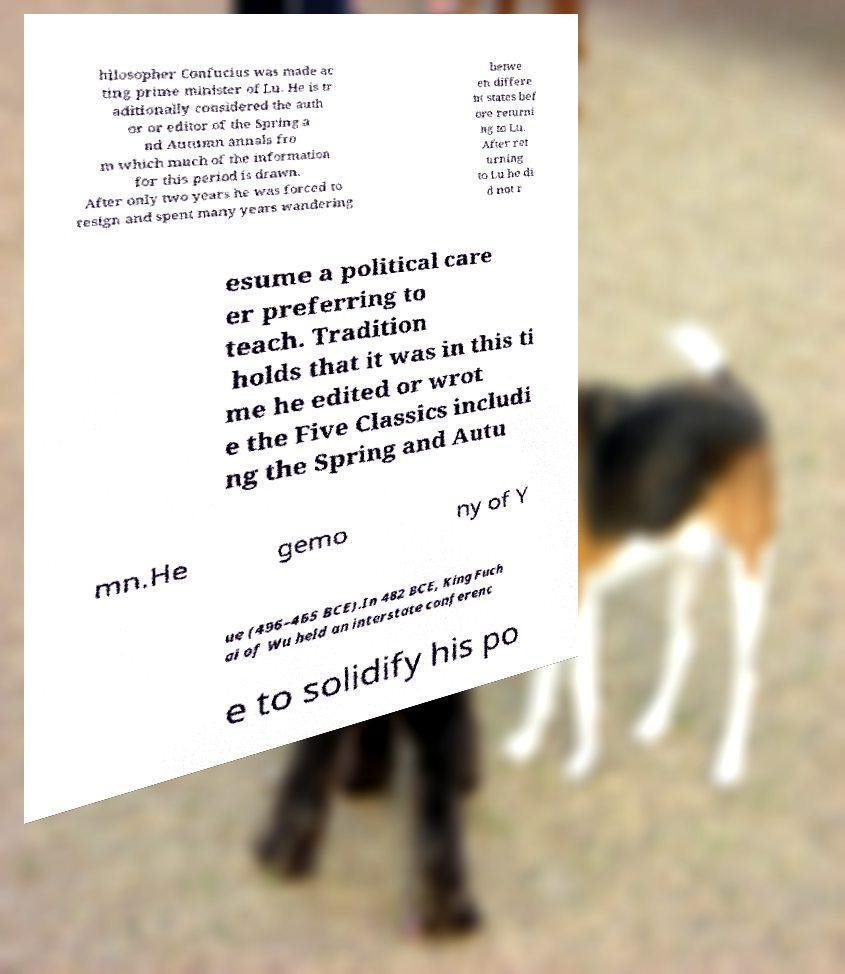What messages or text are displayed in this image? I need them in a readable, typed format. hilosopher Confucius was made ac ting prime minister of Lu. He is tr aditionally considered the auth or or editor of the Spring a nd Autumn annals fro m which much of the information for this period is drawn. After only two years he was forced to resign and spent many years wandering betwe en differe nt states bef ore returni ng to Lu. After ret urning to Lu he di d not r esume a political care er preferring to teach. Tradition holds that it was in this ti me he edited or wrot e the Five Classics includi ng the Spring and Autu mn.He gemo ny of Y ue (496–465 BCE).In 482 BCE, King Fuch ai of Wu held an interstate conferenc e to solidify his po 